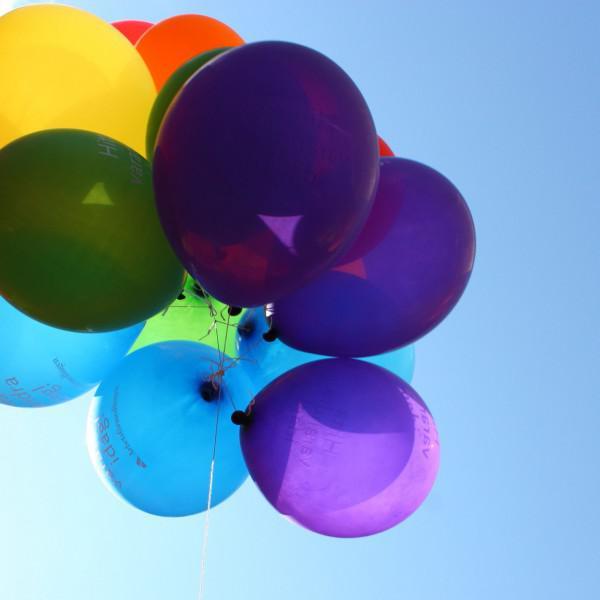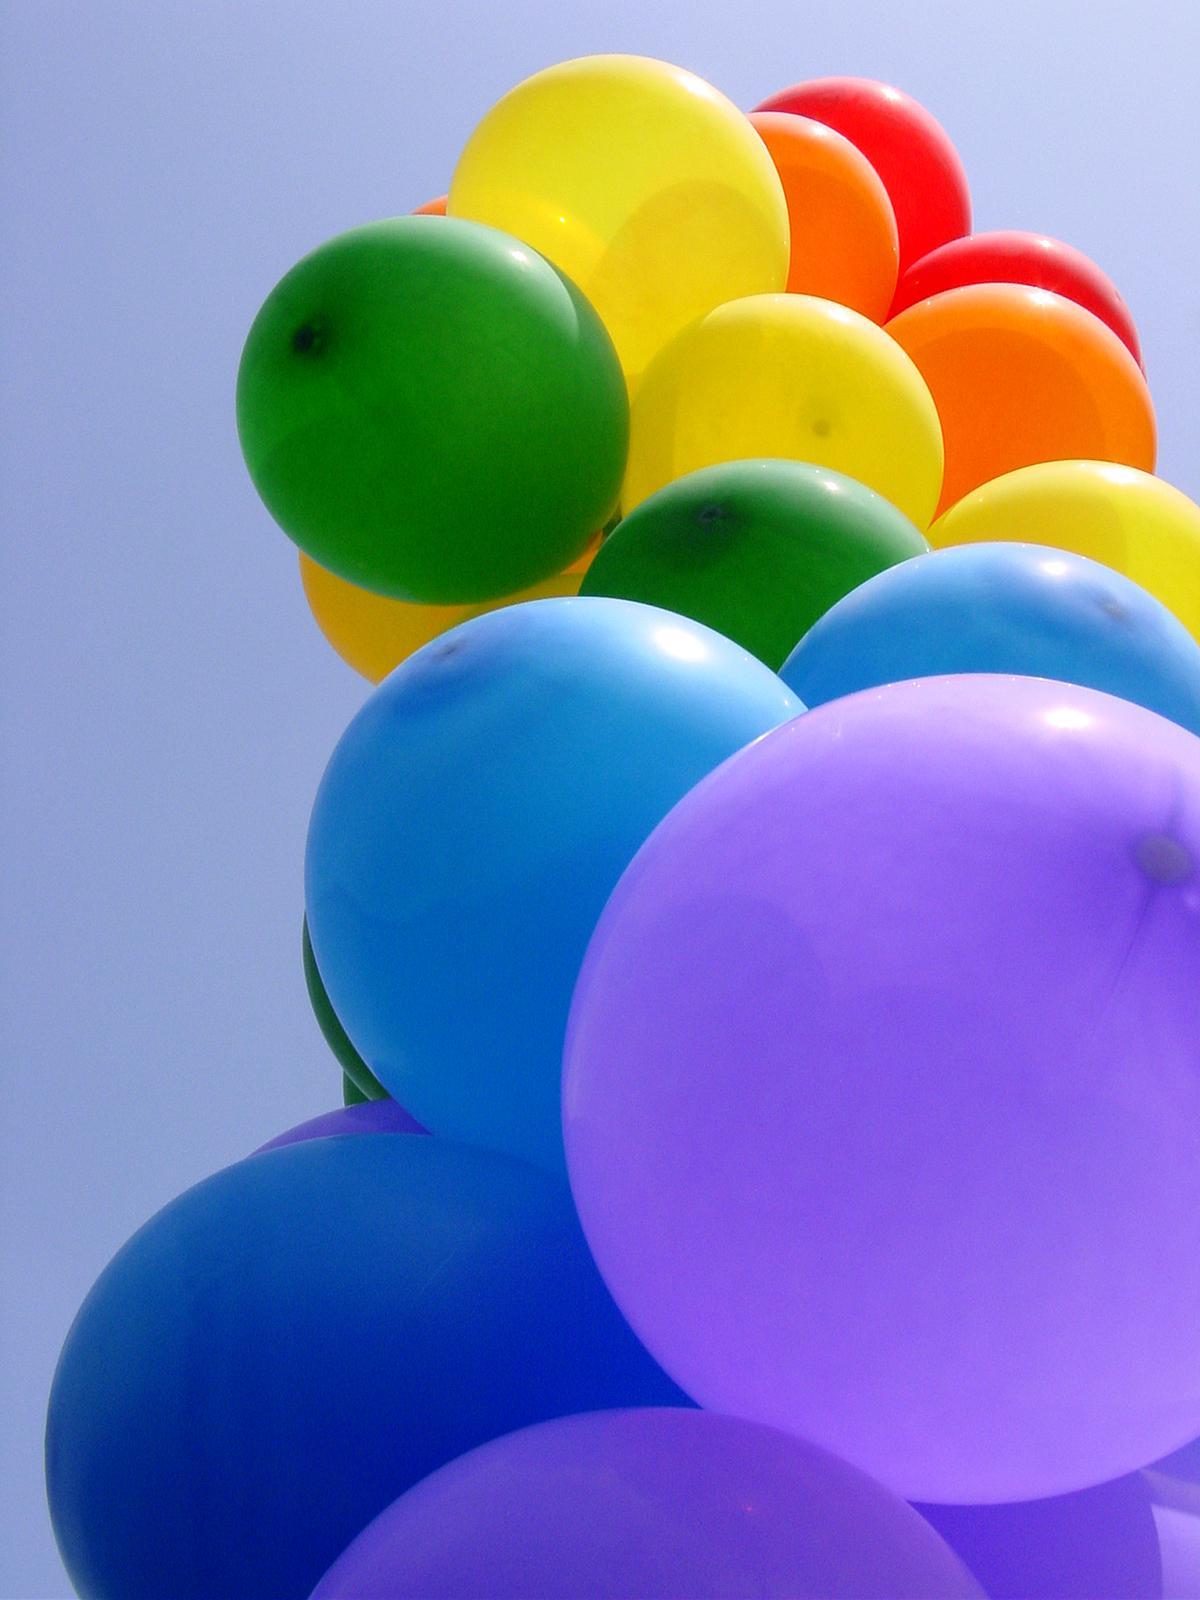The first image is the image on the left, the second image is the image on the right. Assess this claim about the two images: "there are a bunch of balloons gathered together by strings and all the purple balloons are on the bottom". Correct or not? Answer yes or no. Yes. The first image is the image on the left, the second image is the image on the right. For the images shown, is this caption "An image shows an upward view of at least one balloon on a string ascending into a cloud-studded blue sky." true? Answer yes or no. No. 